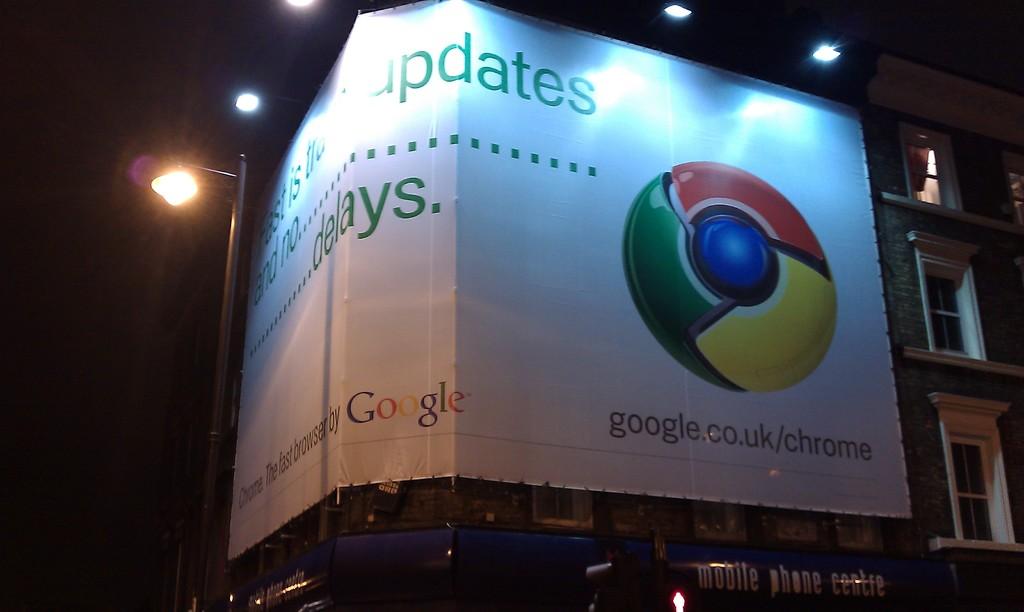What is the company?
Provide a short and direct response. Google. 